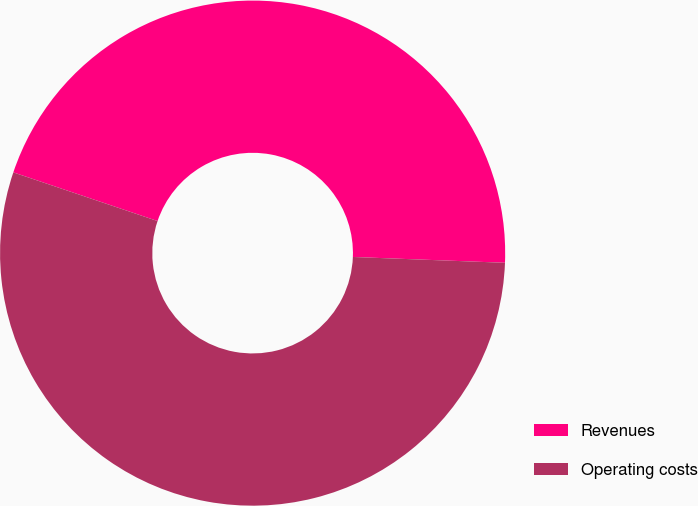Convert chart. <chart><loc_0><loc_0><loc_500><loc_500><pie_chart><fcel>Revenues<fcel>Operating costs<nl><fcel>45.43%<fcel>54.57%<nl></chart> 